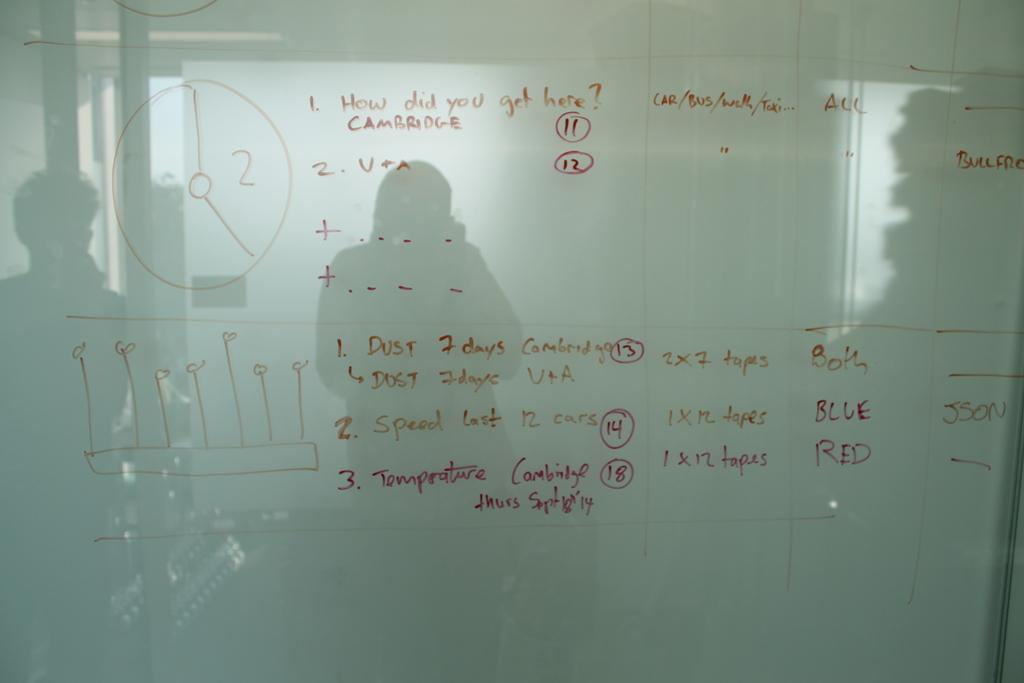Provide a one-sentence caption for the provided image. Whiteboard which says "How did you get here?" on the top. 